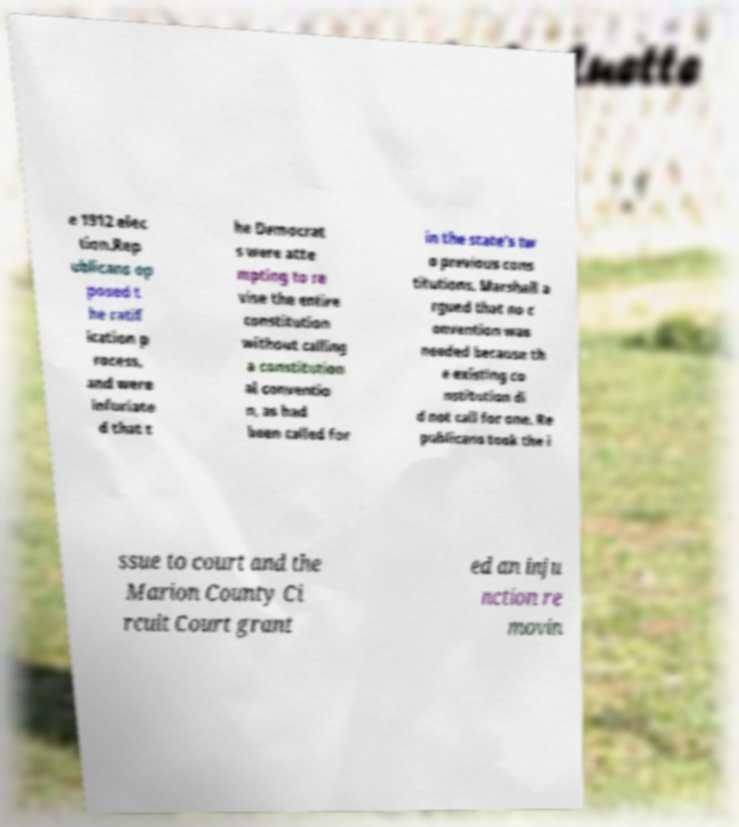For documentation purposes, I need the text within this image transcribed. Could you provide that? e 1912 elec tion.Rep ublicans op posed t he ratif ication p rocess, and were infuriate d that t he Democrat s were atte mpting to re vise the entire constitution without calling a constitution al conventio n, as had been called for in the state's tw o previous cons titutions. Marshall a rgued that no c onvention was needed because th e existing co nstitution di d not call for one. Re publicans took the i ssue to court and the Marion County Ci rcuit Court grant ed an inju nction re movin 